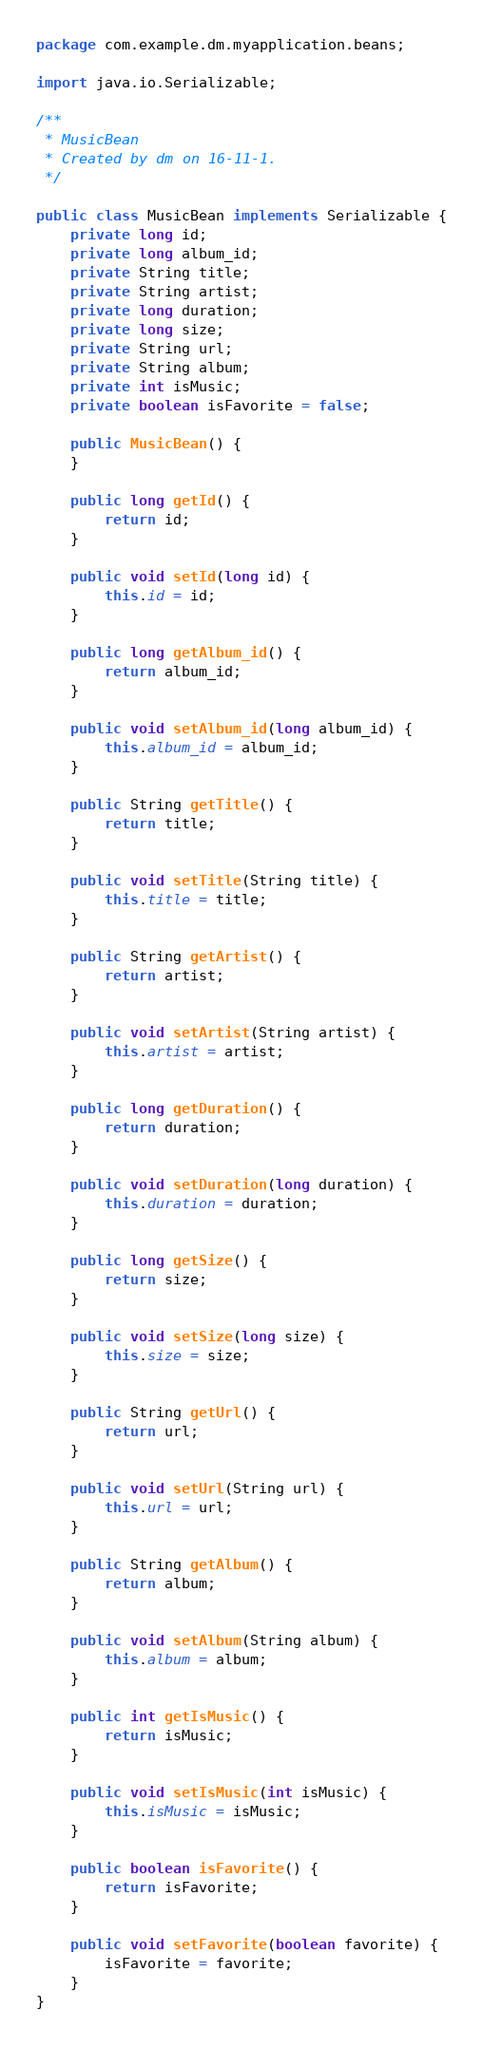<code> <loc_0><loc_0><loc_500><loc_500><_Java_>package com.example.dm.myapplication.beans;

import java.io.Serializable;

/**
 * MusicBean
 * Created by dm on 16-11-1.
 */

public class MusicBean implements Serializable {
    private long id;
    private long album_id;
    private String title;
    private String artist;
    private long duration;
    private long size;
    private String url;
    private String album;
    private int isMusic;
    private boolean isFavorite = false;

    public MusicBean() {
    }

    public long getId() {
        return id;
    }

    public void setId(long id) {
        this.id = id;
    }

    public long getAlbum_id() {
        return album_id;
    }

    public void setAlbum_id(long album_id) {
        this.album_id = album_id;
    }

    public String getTitle() {
        return title;
    }

    public void setTitle(String title) {
        this.title = title;
    }

    public String getArtist() {
        return artist;
    }

    public void setArtist(String artist) {
        this.artist = artist;
    }

    public long getDuration() {
        return duration;
    }

    public void setDuration(long duration) {
        this.duration = duration;
    }

    public long getSize() {
        return size;
    }

    public void setSize(long size) {
        this.size = size;
    }

    public String getUrl() {
        return url;
    }

    public void setUrl(String url) {
        this.url = url;
    }

    public String getAlbum() {
        return album;
    }

    public void setAlbum(String album) {
        this.album = album;
    }

    public int getIsMusic() {
        return isMusic;
    }

    public void setIsMusic(int isMusic) {
        this.isMusic = isMusic;
    }

    public boolean isFavorite() {
        return isFavorite;
    }

    public void setFavorite(boolean favorite) {
        isFavorite = favorite;
    }
}
</code> 